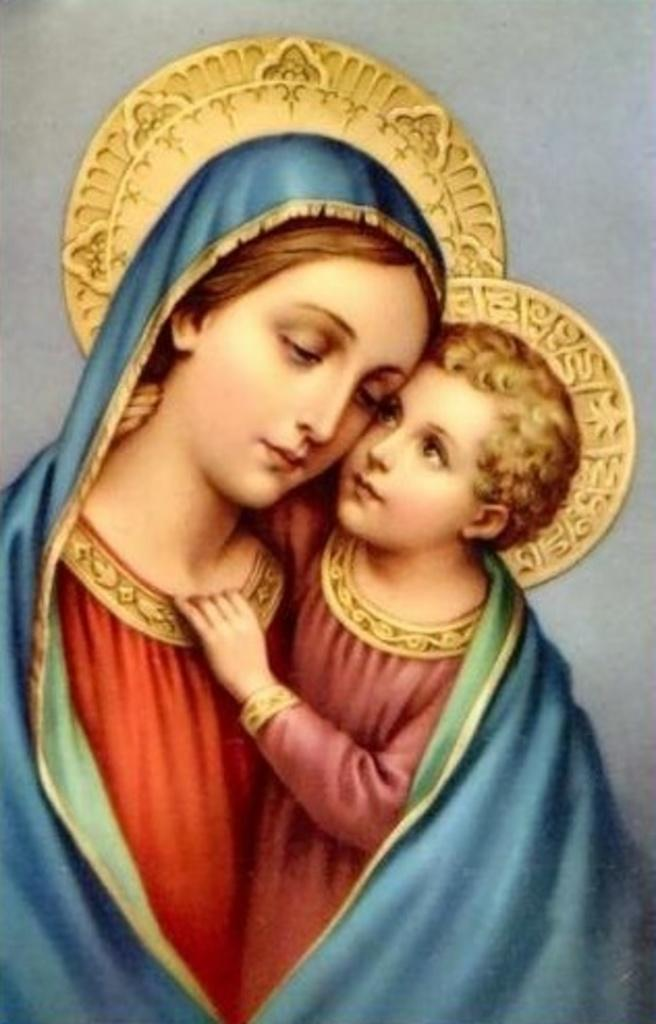Who is the main subject in the image? There is a woman in the image. What is the woman wearing? The woman is wearing a red dress. Can you describe the other person in the image? There is a baby in the image, and the baby is holding the woman. What type of artwork is the image? The image appears to be a painting. What type of plate is visible in the image? There is no plate present in the image. Can you describe the coastline in the image? There is no coastline present in the image; it is a painting of a woman and a baby. 